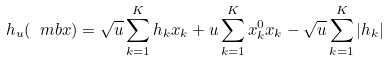<formula> <loc_0><loc_0><loc_500><loc_500>h _ { u } ( \ m b x ) = \sqrt { u } \sum _ { k = 1 } ^ { K } h _ { k } x _ { k } + u \sum _ { k = 1 } ^ { K } x ^ { 0 } _ { k } x _ { k } - \sqrt { u } \sum _ { k = 1 } ^ { K } | h _ { k } |</formula> 